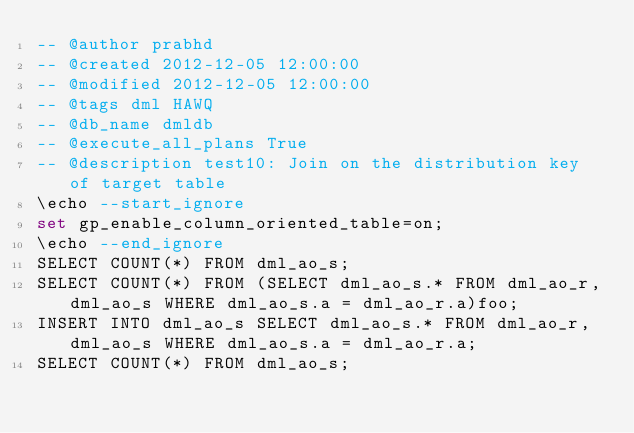<code> <loc_0><loc_0><loc_500><loc_500><_SQL_>-- @author prabhd 
-- @created 2012-12-05 12:00:00 
-- @modified 2012-12-05 12:00:00 
-- @tags dml HAWQ 
-- @db_name dmldb
-- @execute_all_plans True
-- @description test10: Join on the distribution key of target table
\echo --start_ignore
set gp_enable_column_oriented_table=on;
\echo --end_ignore
SELECT COUNT(*) FROM dml_ao_s;
SELECT COUNT(*) FROM (SELECT dml_ao_s.* FROM dml_ao_r,dml_ao_s WHERE dml_ao_s.a = dml_ao_r.a)foo;
INSERT INTO dml_ao_s SELECT dml_ao_s.* FROM dml_ao_r,dml_ao_s WHERE dml_ao_s.a = dml_ao_r.a;
SELECT COUNT(*) FROM dml_ao_s;
</code> 